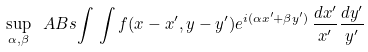Convert formula to latex. <formula><loc_0><loc_0><loc_500><loc_500>\sup _ { \alpha , \beta } \ A B s { \int \, \int f ( x - x ^ { \prime } , y - y ^ { \prime } ) e ^ { i ( \alpha x ^ { \prime } + \beta y ^ { \prime } ) } \, \frac { d x ^ { \prime } } { x ^ { \prime } } \frac { d y ^ { \prime } } { y ^ { \prime } } }</formula> 